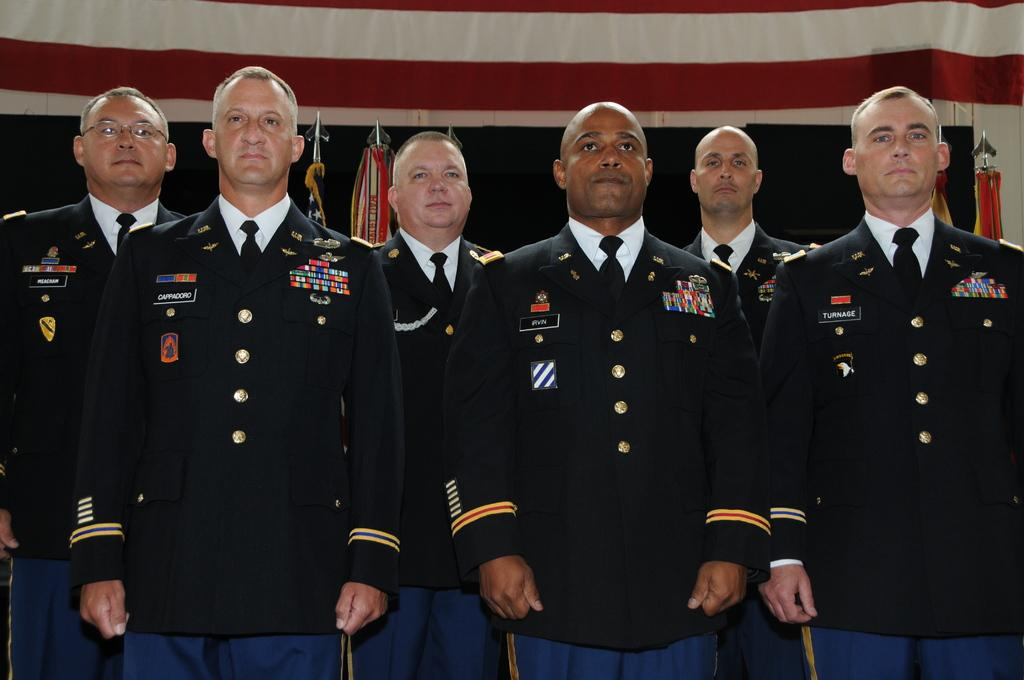What is happening in the image? There are persons standing in the image. What can be seen in the background of the image? There are flags on poles and a cloth visible in the background of the image. What scientific discovery is being celebrated with the flags in the image? There is no indication of a scientific discovery being celebrated in the image; the flags are simply present on poles in the background. 